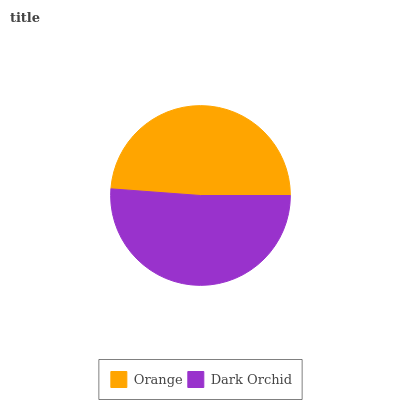Is Orange the minimum?
Answer yes or no. Yes. Is Dark Orchid the maximum?
Answer yes or no. Yes. Is Dark Orchid the minimum?
Answer yes or no. No. Is Dark Orchid greater than Orange?
Answer yes or no. Yes. Is Orange less than Dark Orchid?
Answer yes or no. Yes. Is Orange greater than Dark Orchid?
Answer yes or no. No. Is Dark Orchid less than Orange?
Answer yes or no. No. Is Dark Orchid the high median?
Answer yes or no. Yes. Is Orange the low median?
Answer yes or no. Yes. Is Orange the high median?
Answer yes or no. No. Is Dark Orchid the low median?
Answer yes or no. No. 